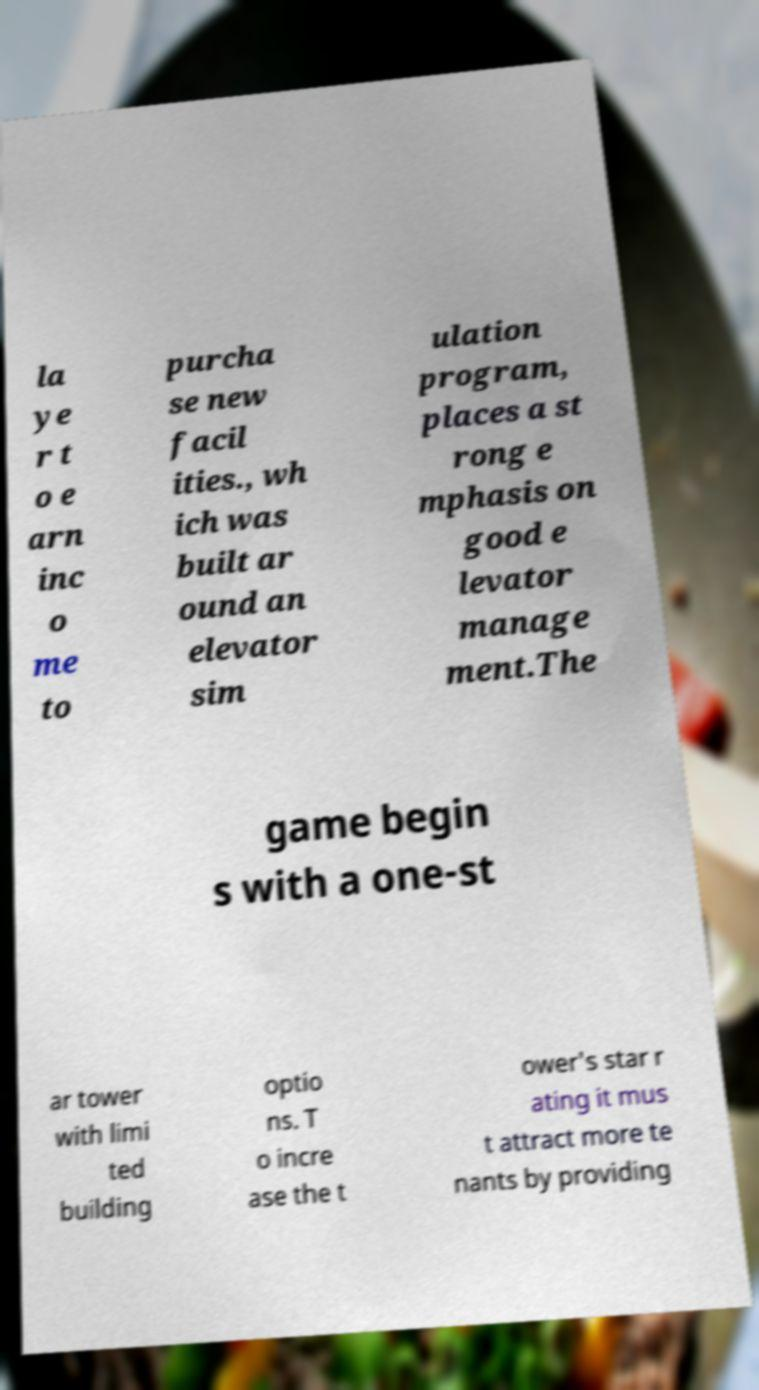I need the written content from this picture converted into text. Can you do that? la ye r t o e arn inc o me to purcha se new facil ities., wh ich was built ar ound an elevator sim ulation program, places a st rong e mphasis on good e levator manage ment.The game begin s with a one-st ar tower with limi ted building optio ns. T o incre ase the t ower's star r ating it mus t attract more te nants by providing 